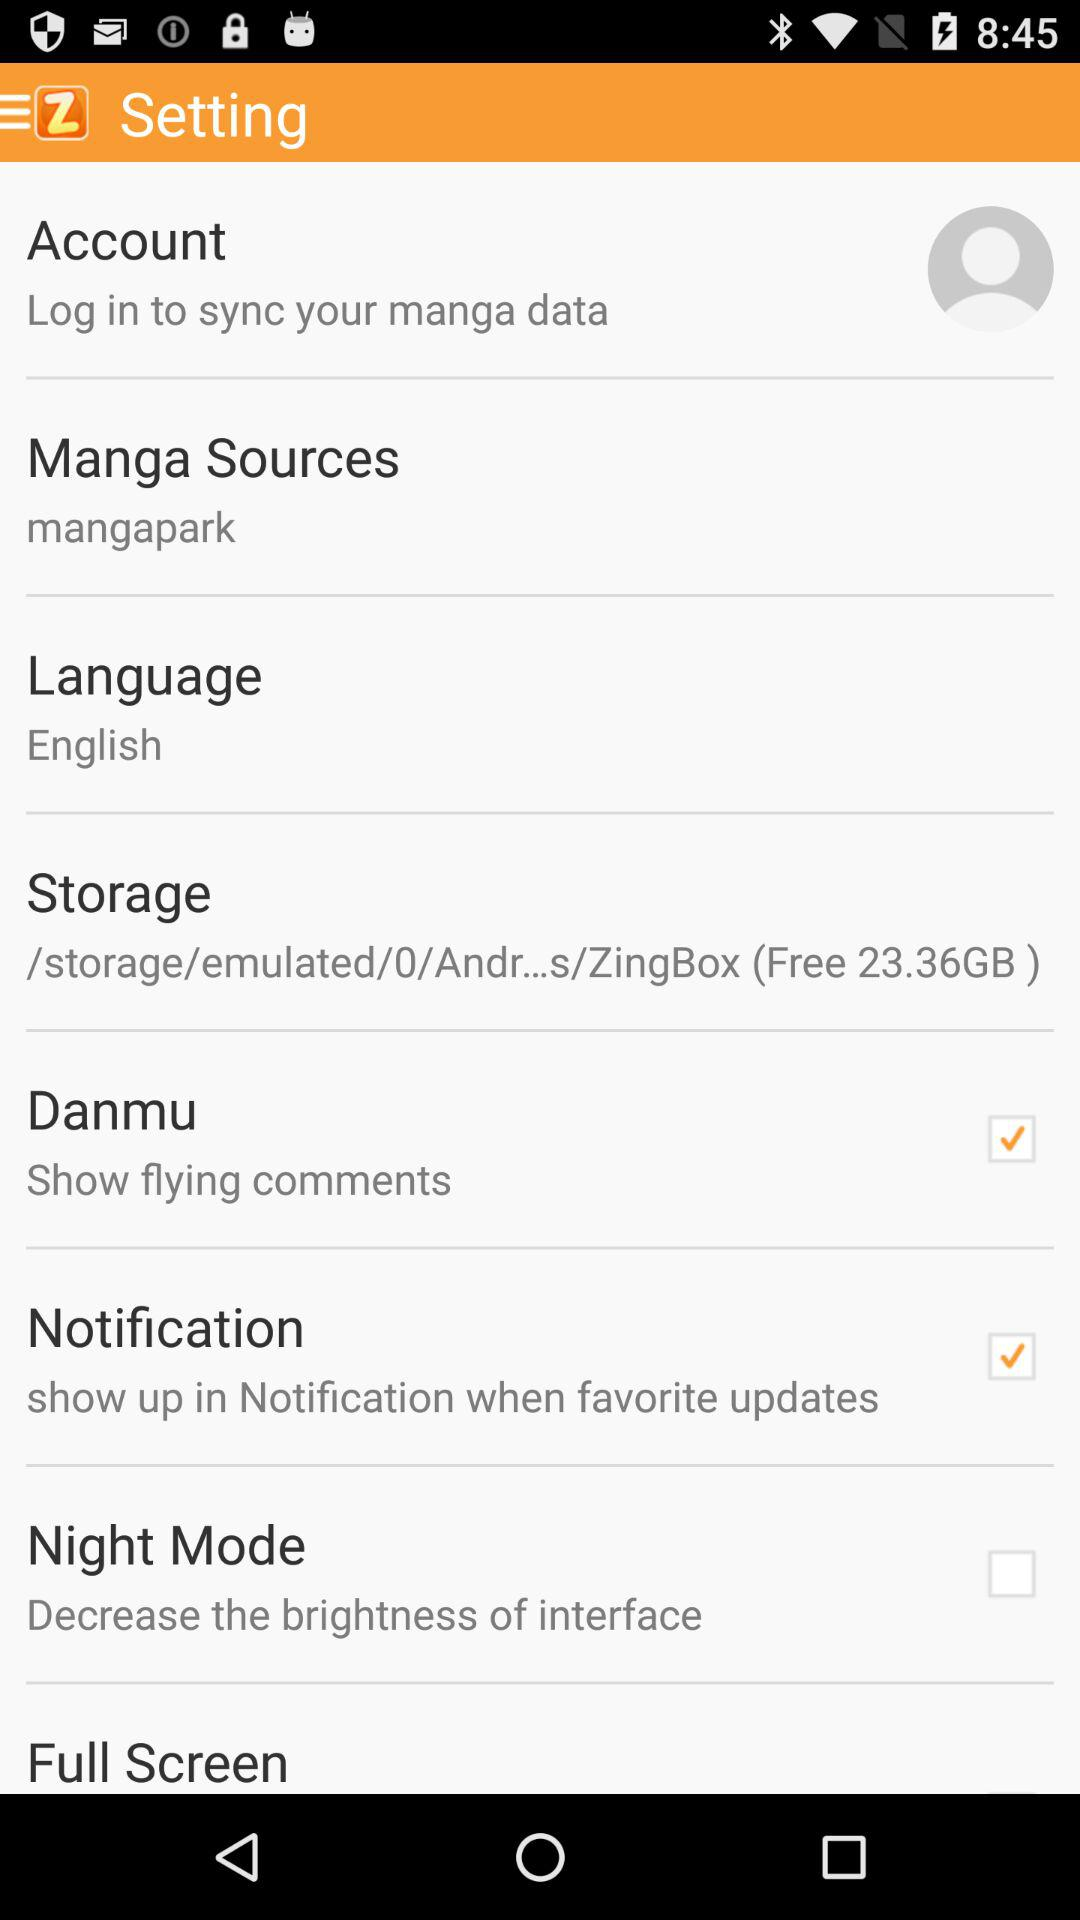What's the storage path? The storage path is "/storage/emulated/0/Andr...s/ZingBox". 